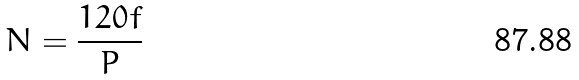Convert formula to latex. <formula><loc_0><loc_0><loc_500><loc_500>N = \frac { 1 2 0 f } { P }</formula> 